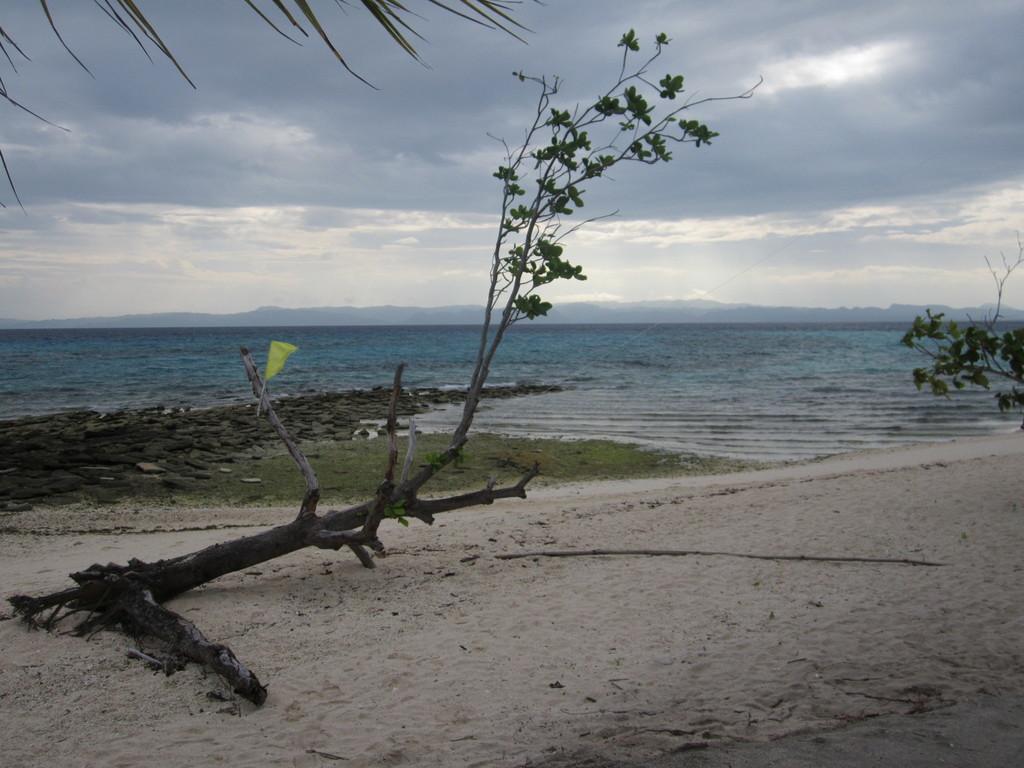Can you describe this image briefly? In this image we can see the sea. In front of the sea we can see the grass, rocks, trees and the sand. In the background, we can see the mountains. At the top we can see the sky. 